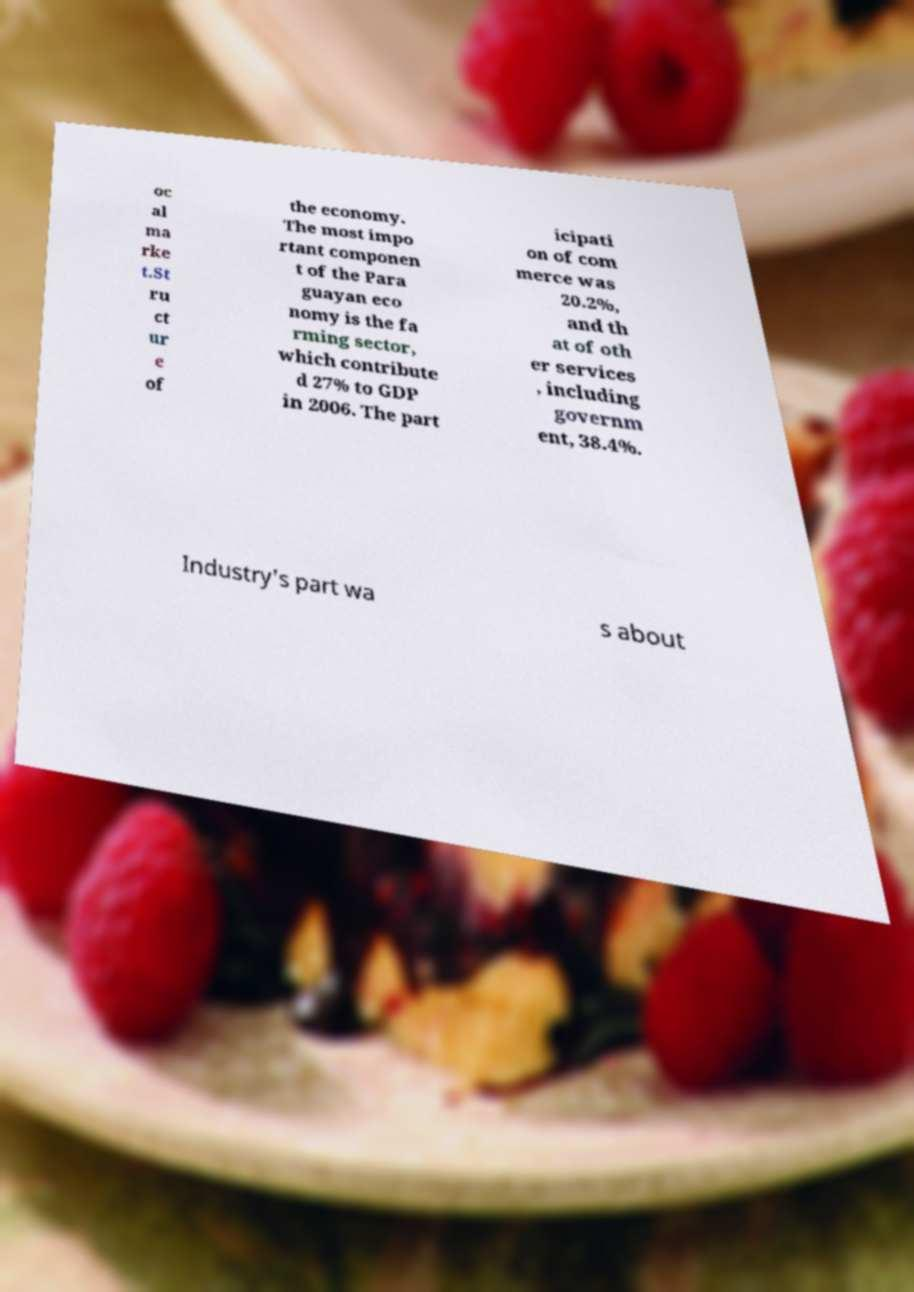I need the written content from this picture converted into text. Can you do that? oc al ma rke t.St ru ct ur e of the economy. The most impo rtant componen t of the Para guayan eco nomy is the fa rming sector, which contribute d 27% to GDP in 2006. The part icipati on of com merce was 20.2%, and th at of oth er services , including governm ent, 38.4%. Industry's part wa s about 